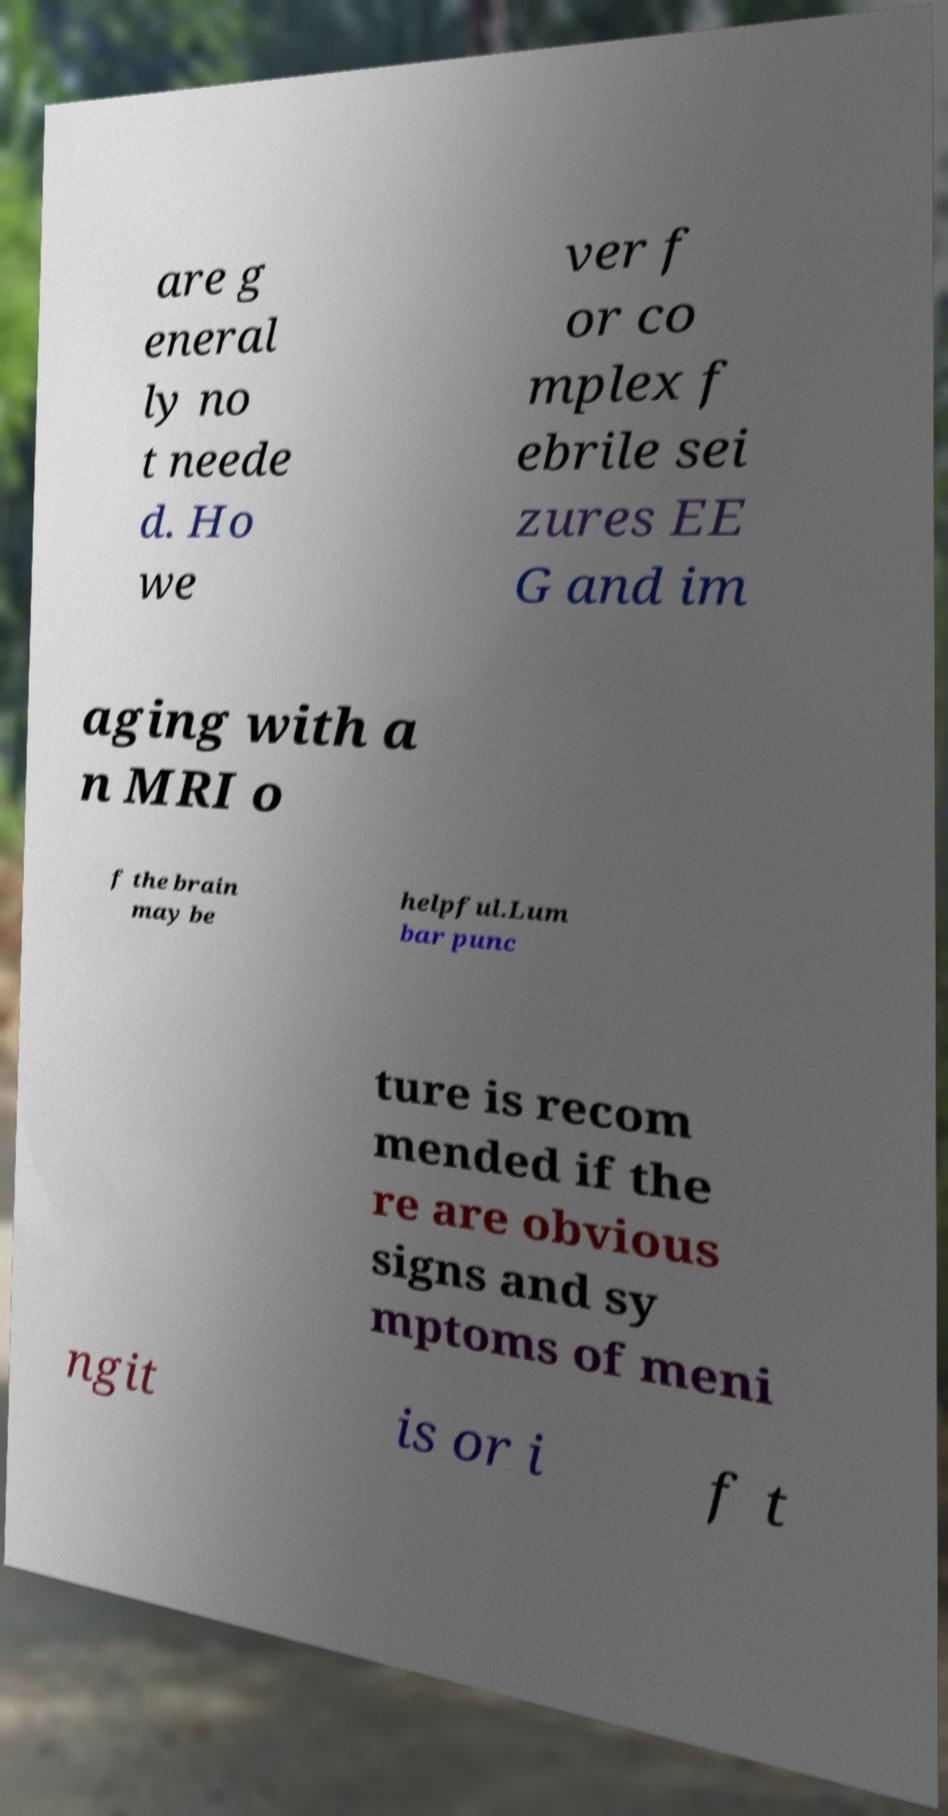For documentation purposes, I need the text within this image transcribed. Could you provide that? are g eneral ly no t neede d. Ho we ver f or co mplex f ebrile sei zures EE G and im aging with a n MRI o f the brain may be helpful.Lum bar punc ture is recom mended if the re are obvious signs and sy mptoms of meni ngit is or i f t 